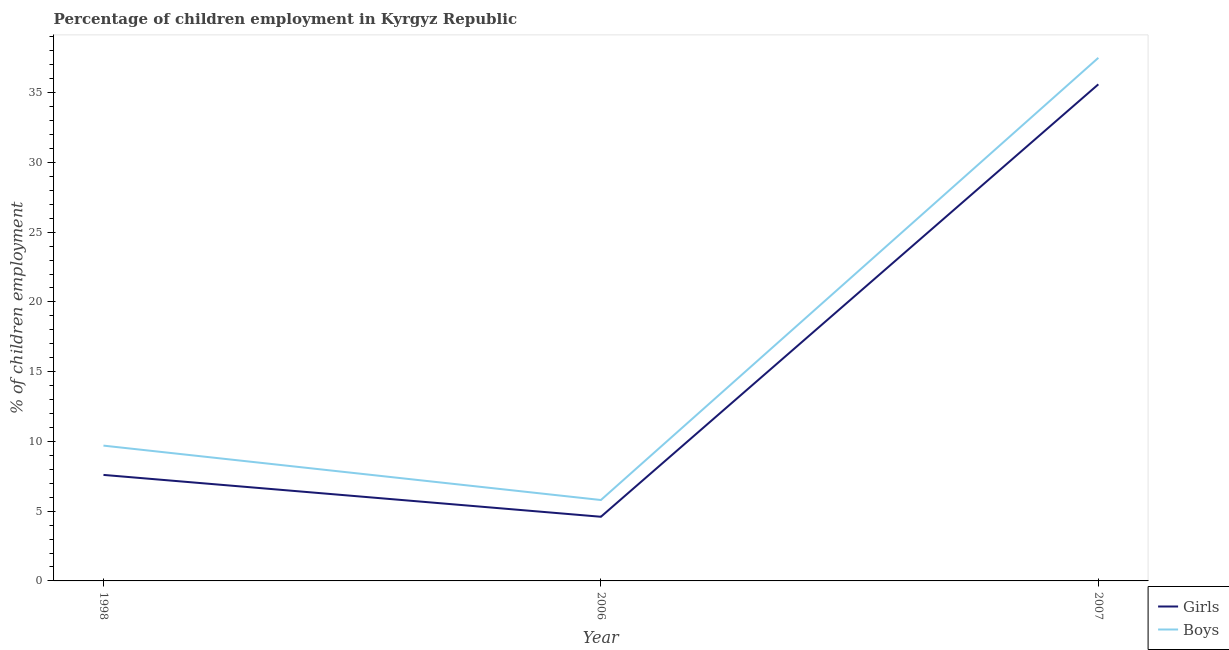How many different coloured lines are there?
Your answer should be very brief. 2. Is the number of lines equal to the number of legend labels?
Your answer should be very brief. Yes. Across all years, what is the maximum percentage of employed girls?
Offer a terse response. 35.6. Across all years, what is the minimum percentage of employed girls?
Give a very brief answer. 4.6. In which year was the percentage of employed boys maximum?
Ensure brevity in your answer.  2007. In which year was the percentage of employed boys minimum?
Provide a short and direct response. 2006. What is the total percentage of employed girls in the graph?
Offer a very short reply. 47.8. What is the difference between the percentage of employed boys in 2006 and that in 2007?
Your response must be concise. -31.7. What is the difference between the percentage of employed boys in 1998 and the percentage of employed girls in 2007?
Offer a very short reply. -25.9. What is the average percentage of employed girls per year?
Provide a succinct answer. 15.93. In the year 2007, what is the difference between the percentage of employed boys and percentage of employed girls?
Your answer should be compact. 1.9. In how many years, is the percentage of employed boys greater than 37 %?
Ensure brevity in your answer.  1. What is the ratio of the percentage of employed girls in 1998 to that in 2007?
Make the answer very short. 0.21. Is the percentage of employed girls in 1998 less than that in 2007?
Give a very brief answer. Yes. What is the difference between the highest and the second highest percentage of employed boys?
Offer a terse response. 27.8. In how many years, is the percentage of employed boys greater than the average percentage of employed boys taken over all years?
Give a very brief answer. 1. Is the sum of the percentage of employed boys in 2006 and 2007 greater than the maximum percentage of employed girls across all years?
Offer a very short reply. Yes. Is the percentage of employed girls strictly less than the percentage of employed boys over the years?
Give a very brief answer. Yes. How many lines are there?
Make the answer very short. 2. How many years are there in the graph?
Your answer should be very brief. 3. Are the values on the major ticks of Y-axis written in scientific E-notation?
Provide a succinct answer. No. Does the graph contain grids?
Provide a short and direct response. No. Where does the legend appear in the graph?
Offer a terse response. Bottom right. How many legend labels are there?
Make the answer very short. 2. How are the legend labels stacked?
Give a very brief answer. Vertical. What is the title of the graph?
Your answer should be very brief. Percentage of children employment in Kyrgyz Republic. What is the label or title of the X-axis?
Provide a succinct answer. Year. What is the label or title of the Y-axis?
Ensure brevity in your answer.  % of children employment. What is the % of children employment of Girls in 1998?
Provide a succinct answer. 7.6. What is the % of children employment of Girls in 2007?
Your response must be concise. 35.6. What is the % of children employment of Boys in 2007?
Give a very brief answer. 37.5. Across all years, what is the maximum % of children employment of Girls?
Offer a very short reply. 35.6. Across all years, what is the maximum % of children employment of Boys?
Keep it short and to the point. 37.5. Across all years, what is the minimum % of children employment of Girls?
Provide a succinct answer. 4.6. What is the total % of children employment of Girls in the graph?
Make the answer very short. 47.8. What is the total % of children employment in Boys in the graph?
Your answer should be very brief. 53. What is the difference between the % of children employment of Girls in 1998 and that in 2006?
Make the answer very short. 3. What is the difference between the % of children employment in Boys in 1998 and that in 2006?
Your answer should be compact. 3.9. What is the difference between the % of children employment of Girls in 1998 and that in 2007?
Ensure brevity in your answer.  -28. What is the difference between the % of children employment in Boys in 1998 and that in 2007?
Offer a very short reply. -27.8. What is the difference between the % of children employment in Girls in 2006 and that in 2007?
Make the answer very short. -31. What is the difference between the % of children employment of Boys in 2006 and that in 2007?
Your answer should be compact. -31.7. What is the difference between the % of children employment in Girls in 1998 and the % of children employment in Boys in 2006?
Make the answer very short. 1.8. What is the difference between the % of children employment of Girls in 1998 and the % of children employment of Boys in 2007?
Ensure brevity in your answer.  -29.9. What is the difference between the % of children employment of Girls in 2006 and the % of children employment of Boys in 2007?
Offer a terse response. -32.9. What is the average % of children employment in Girls per year?
Provide a short and direct response. 15.93. What is the average % of children employment in Boys per year?
Provide a succinct answer. 17.67. In the year 1998, what is the difference between the % of children employment in Girls and % of children employment in Boys?
Provide a succinct answer. -2.1. What is the ratio of the % of children employment of Girls in 1998 to that in 2006?
Provide a succinct answer. 1.65. What is the ratio of the % of children employment in Boys in 1998 to that in 2006?
Your response must be concise. 1.67. What is the ratio of the % of children employment in Girls in 1998 to that in 2007?
Give a very brief answer. 0.21. What is the ratio of the % of children employment of Boys in 1998 to that in 2007?
Keep it short and to the point. 0.26. What is the ratio of the % of children employment in Girls in 2006 to that in 2007?
Give a very brief answer. 0.13. What is the ratio of the % of children employment in Boys in 2006 to that in 2007?
Provide a succinct answer. 0.15. What is the difference between the highest and the second highest % of children employment in Boys?
Give a very brief answer. 27.8. What is the difference between the highest and the lowest % of children employment of Boys?
Make the answer very short. 31.7. 